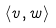<formula> <loc_0><loc_0><loc_500><loc_500>\langle v , w \rangle</formula> 